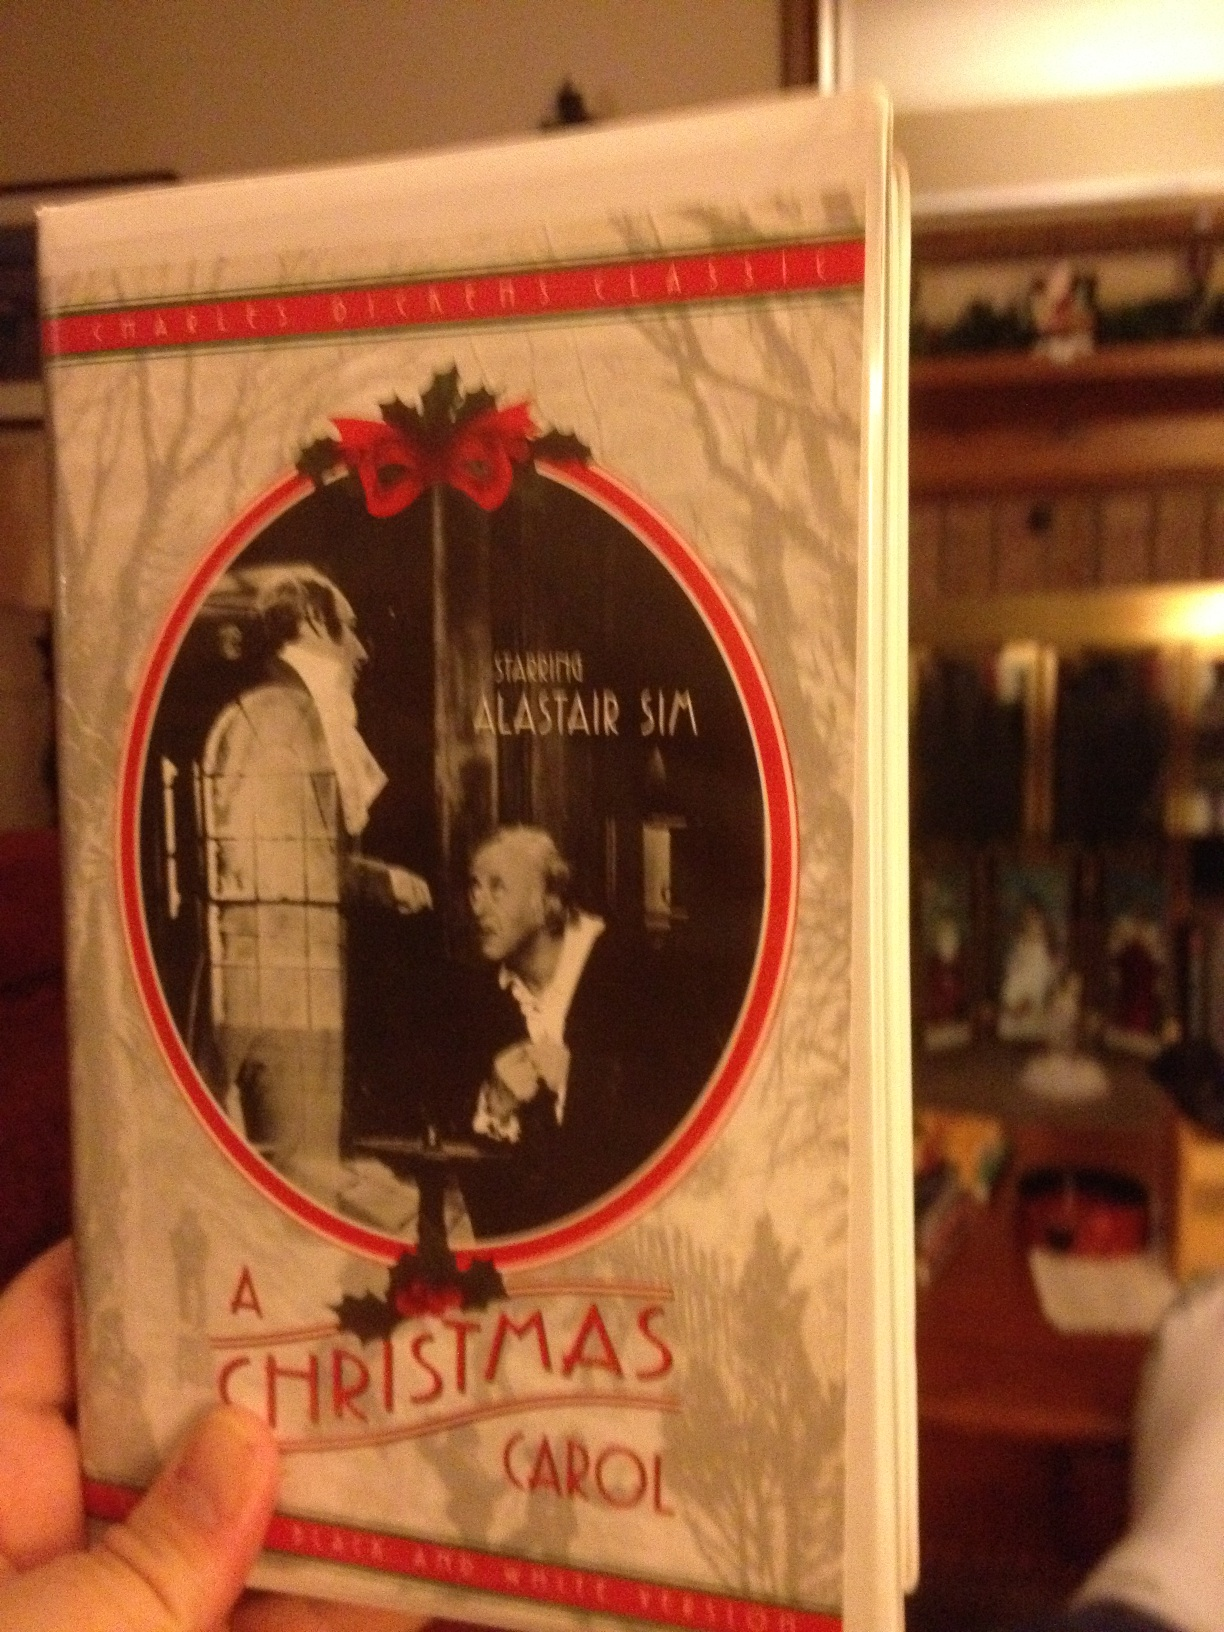What is the significance of the ghosts in the story? The ghosts in 'A Christmas Carol' are crucial to the story’s moral and thematic structure. Each spirit represents different aspects of time: the Ghost of Christmas Past emphasizes reflecting on and learning from past actions; the Ghost of Christmas Present highlights the importance of living in the moment and appreciating the current joys and sorrows of life; and the Ghost of Christmas Yet to Come underscores the potentially grim consequences of continuing down a path of greed and selfishness. Together, they guide Scrooge on a journey of self-awareness and redemption, showing him that it’s within his power to change his fate through compassion and generosity. Their supernatural intervention underscores the redemptive power of introspection and transformation. 